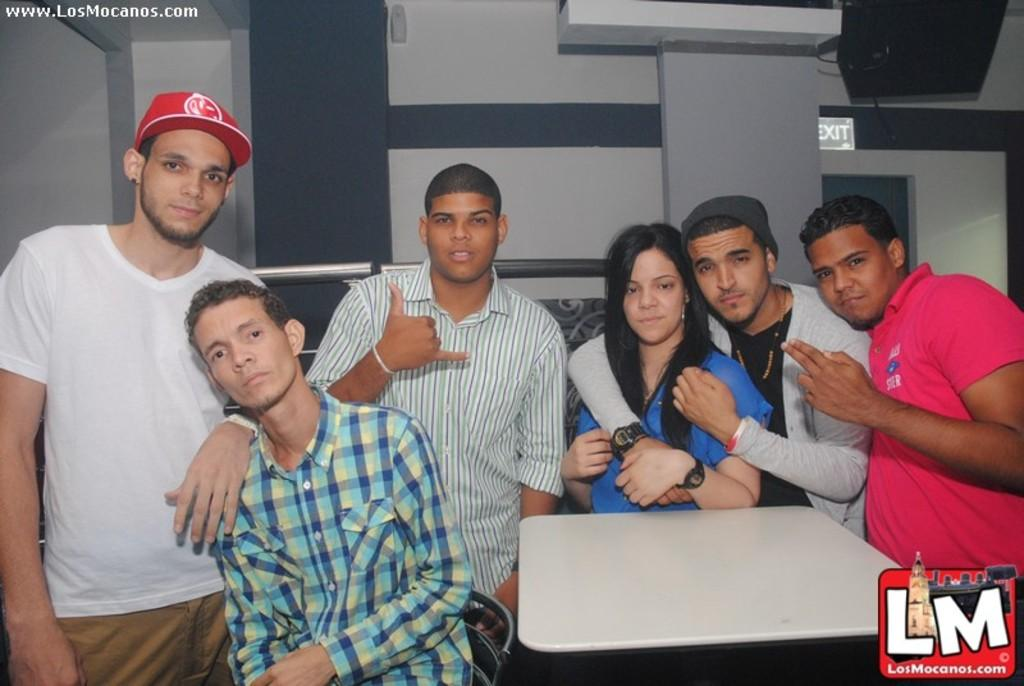What are the people in the image doing? There is a group of people standing in the image. What object can be seen in the image besides the people? There is a table in the image. What is the color of the table? The table is white in color. What can be seen in the background of the image? There is an exit board visible in the background. What type of yoke is being used by the parent in the image? There is no yoke or parent present in the image. Can you tell me how many drums are visible in the image? There are no drums present in the image. 